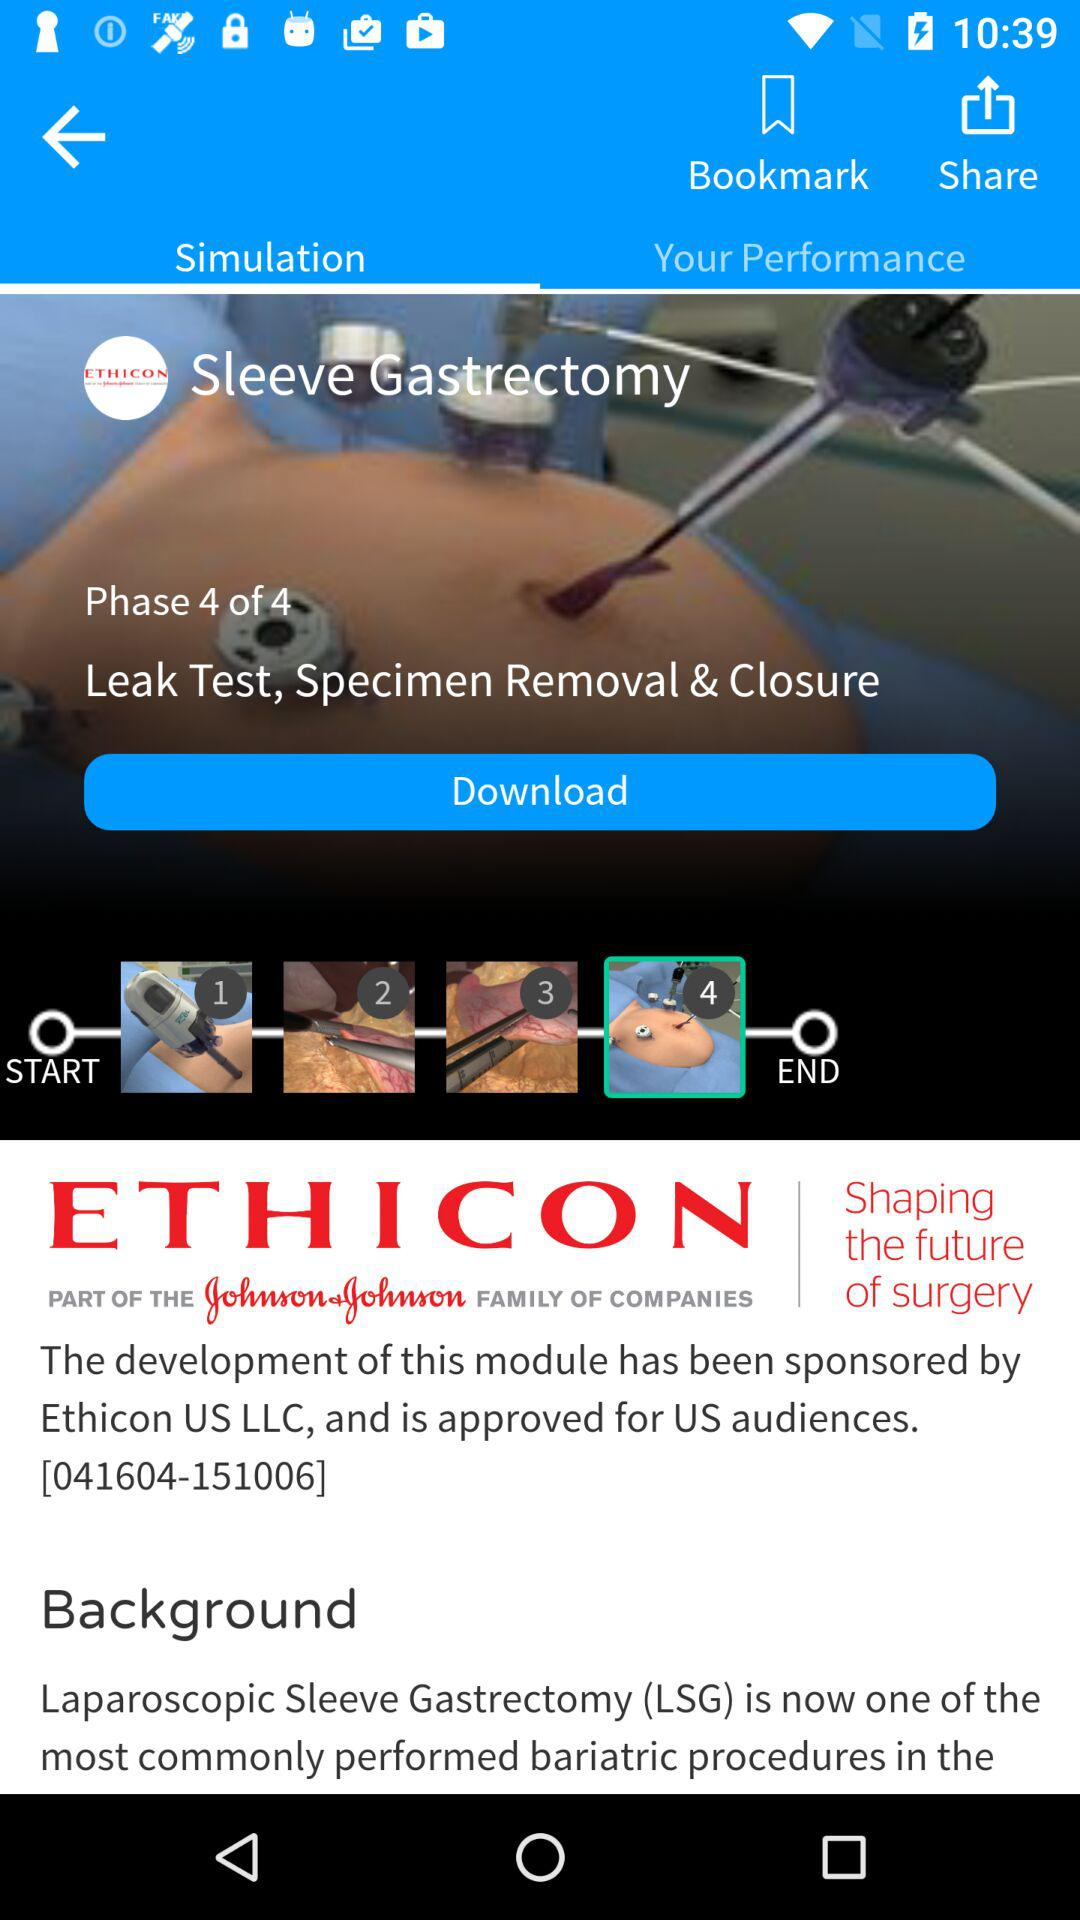How many phases are there in this simulation?
Answer the question using a single word or phrase. 4 